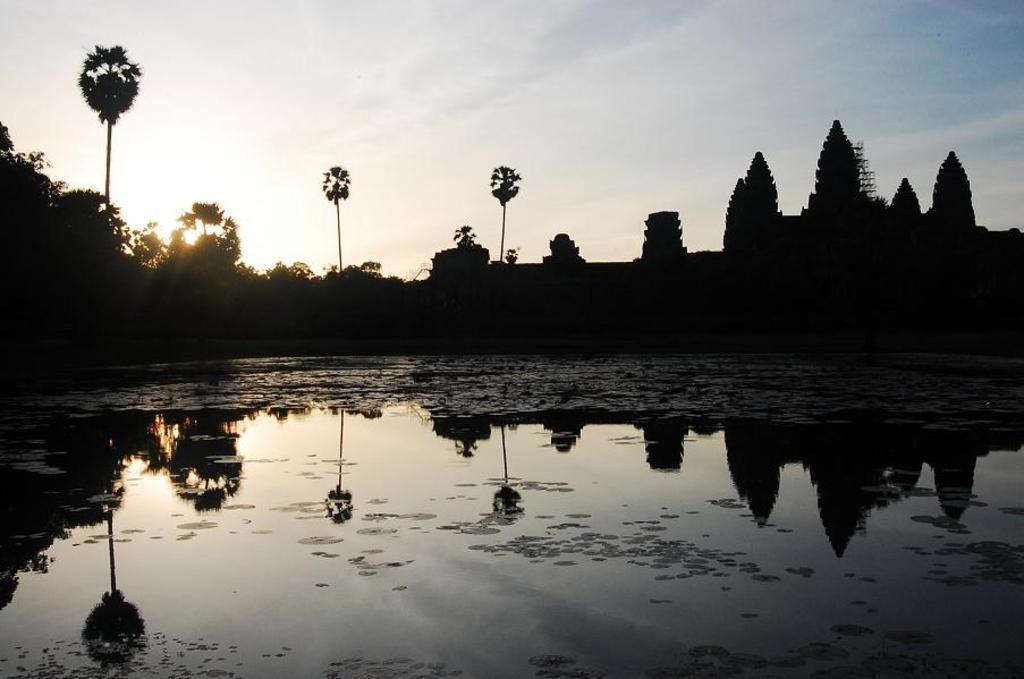Describe this image in one or two sentences. This image consists of water at the bottom. There are trees in the middle. There is sky at the top. There is something like a building on the right side. 